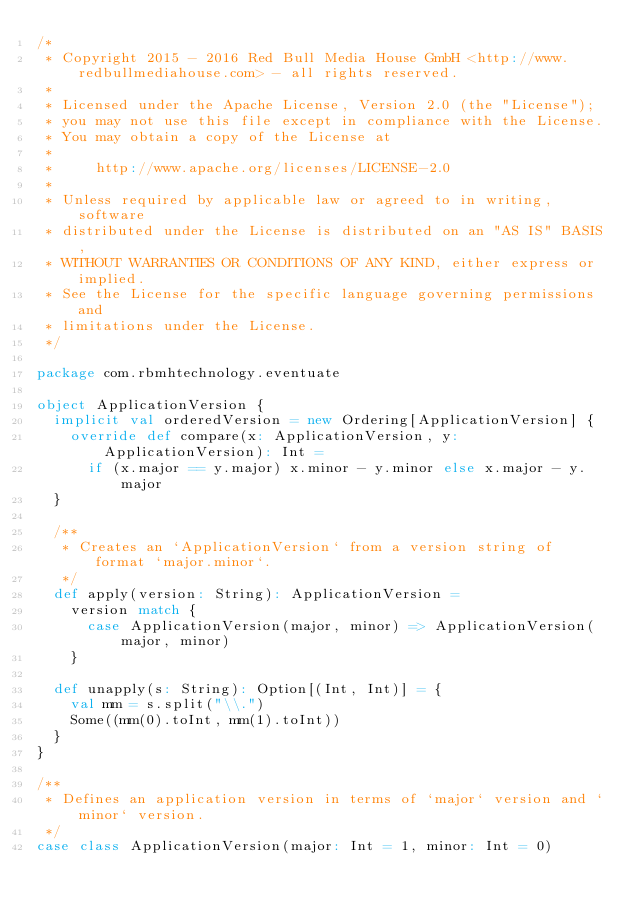<code> <loc_0><loc_0><loc_500><loc_500><_Scala_>/*
 * Copyright 2015 - 2016 Red Bull Media House GmbH <http://www.redbullmediahouse.com> - all rights reserved.
 *
 * Licensed under the Apache License, Version 2.0 (the "License");
 * you may not use this file except in compliance with the License.
 * You may obtain a copy of the License at
 *
 *     http://www.apache.org/licenses/LICENSE-2.0
 *
 * Unless required by applicable law or agreed to in writing, software
 * distributed under the License is distributed on an "AS IS" BASIS,
 * WITHOUT WARRANTIES OR CONDITIONS OF ANY KIND, either express or implied.
 * See the License for the specific language governing permissions and
 * limitations under the License.
 */

package com.rbmhtechnology.eventuate

object ApplicationVersion {
  implicit val orderedVersion = new Ordering[ApplicationVersion] {
    override def compare(x: ApplicationVersion, y: ApplicationVersion): Int =
      if (x.major == y.major) x.minor - y.minor else x.major - y.major
  }

  /**
   * Creates an `ApplicationVersion` from a version string of format `major.minor`.
   */
  def apply(version: String): ApplicationVersion =
    version match {
      case ApplicationVersion(major, minor) => ApplicationVersion(major, minor)
    }

  def unapply(s: String): Option[(Int, Int)] = {
    val mm = s.split("\\.")
    Some((mm(0).toInt, mm(1).toInt))
  }
}

/**
 * Defines an application version in terms of `major` version and `minor` version.
 */
case class ApplicationVersion(major: Int = 1, minor: Int = 0)
</code> 